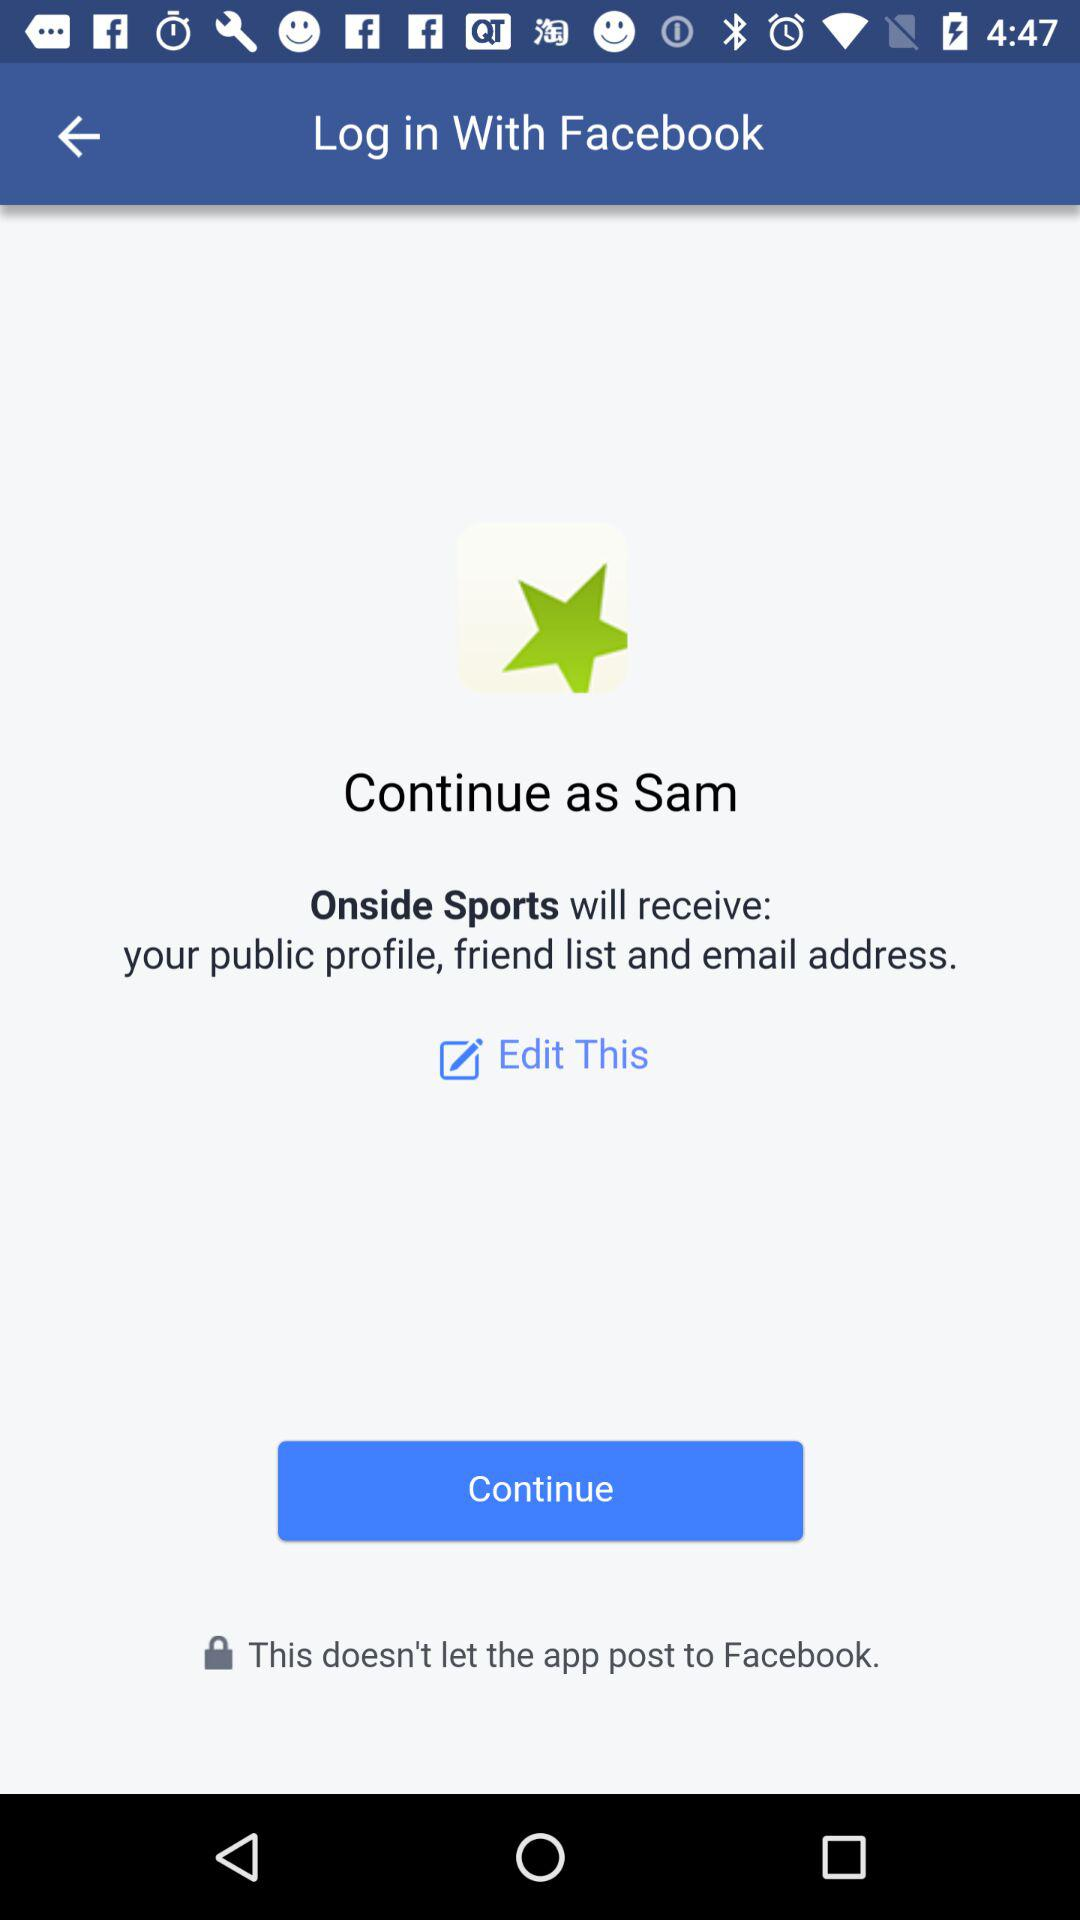With what applications can the user log in? The user can log in with "Facebook". 